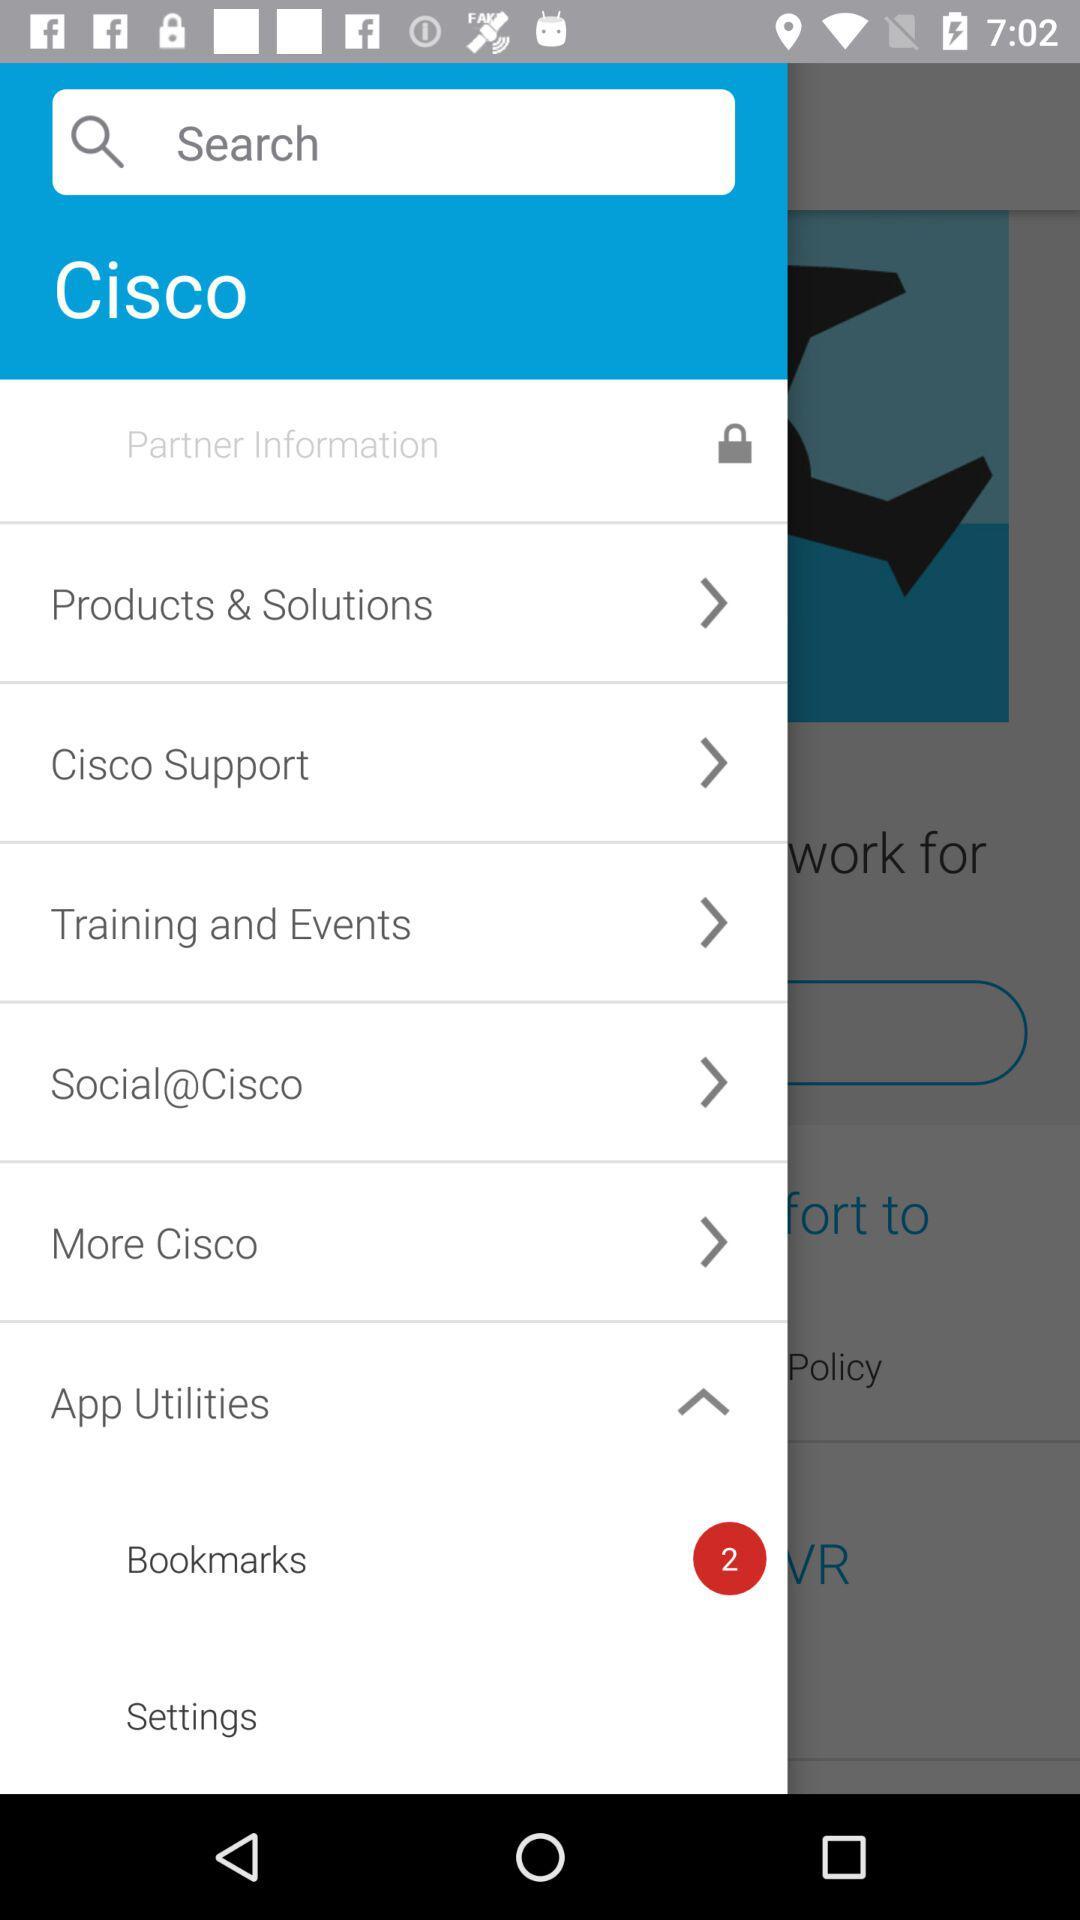How many bookmarks are there? There are 2 bookmarks. 